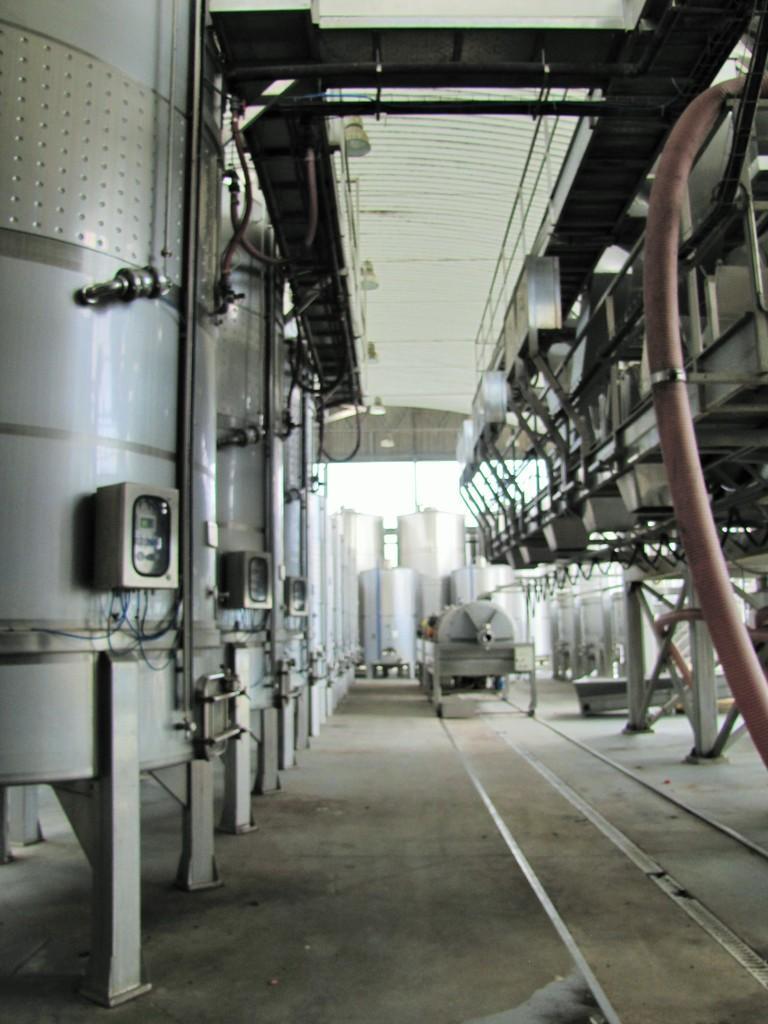How would you summarize this image in a sentence or two? In this picture I can see many machines on either side of the path. 